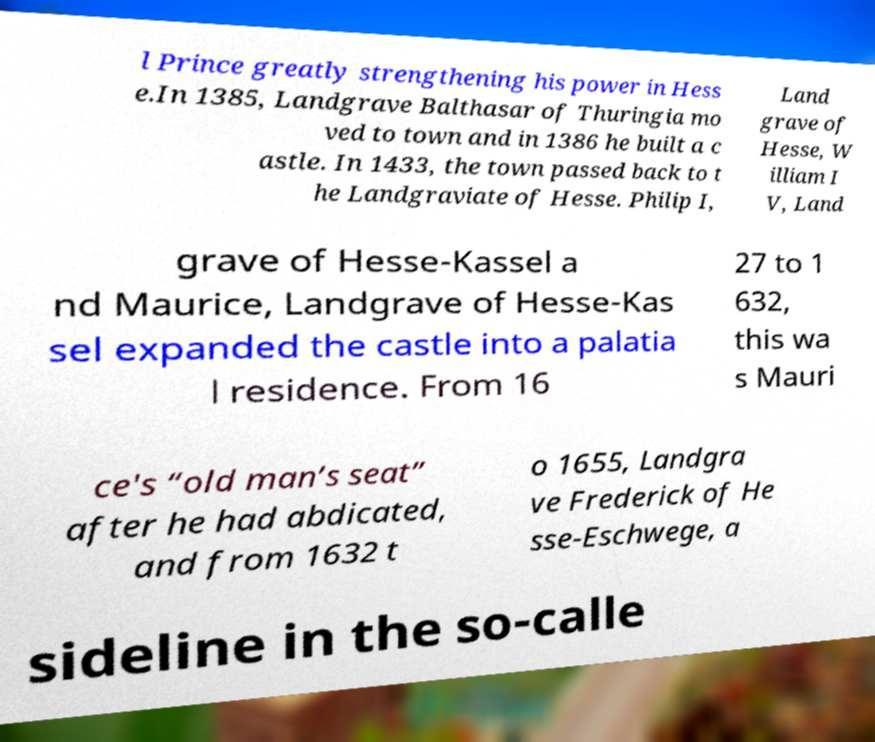Please read and relay the text visible in this image. What does it say? l Prince greatly strengthening his power in Hess e.In 1385, Landgrave Balthasar of Thuringia mo ved to town and in 1386 he built a c astle. In 1433, the town passed back to t he Landgraviate of Hesse. Philip I, Land grave of Hesse, W illiam I V, Land grave of Hesse-Kassel a nd Maurice, Landgrave of Hesse-Kas sel expanded the castle into a palatia l residence. From 16 27 to 1 632, this wa s Mauri ce's “old man’s seat” after he had abdicated, and from 1632 t o 1655, Landgra ve Frederick of He sse-Eschwege, a sideline in the so-calle 